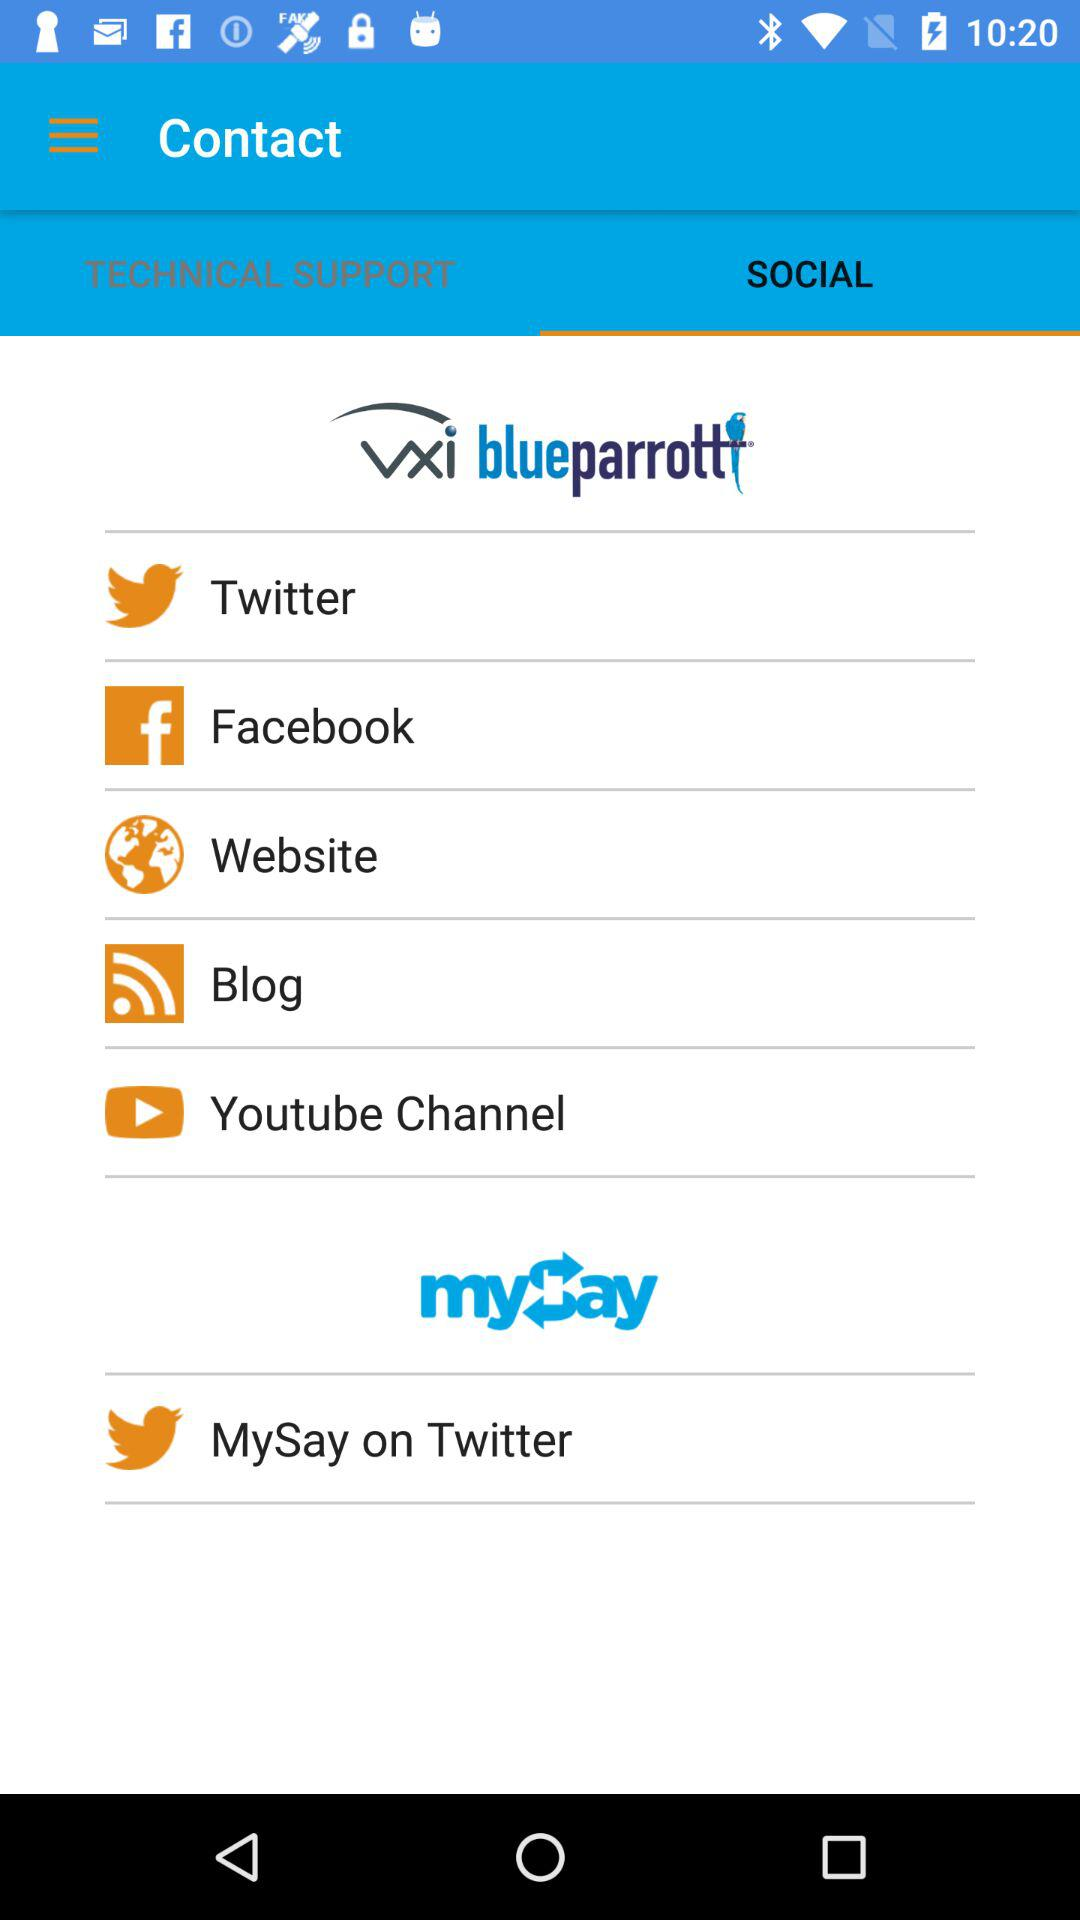What are the available apps? The available apps are "Twitter", "Facebook", "Website", "Blog" and "Youtube Channel". 